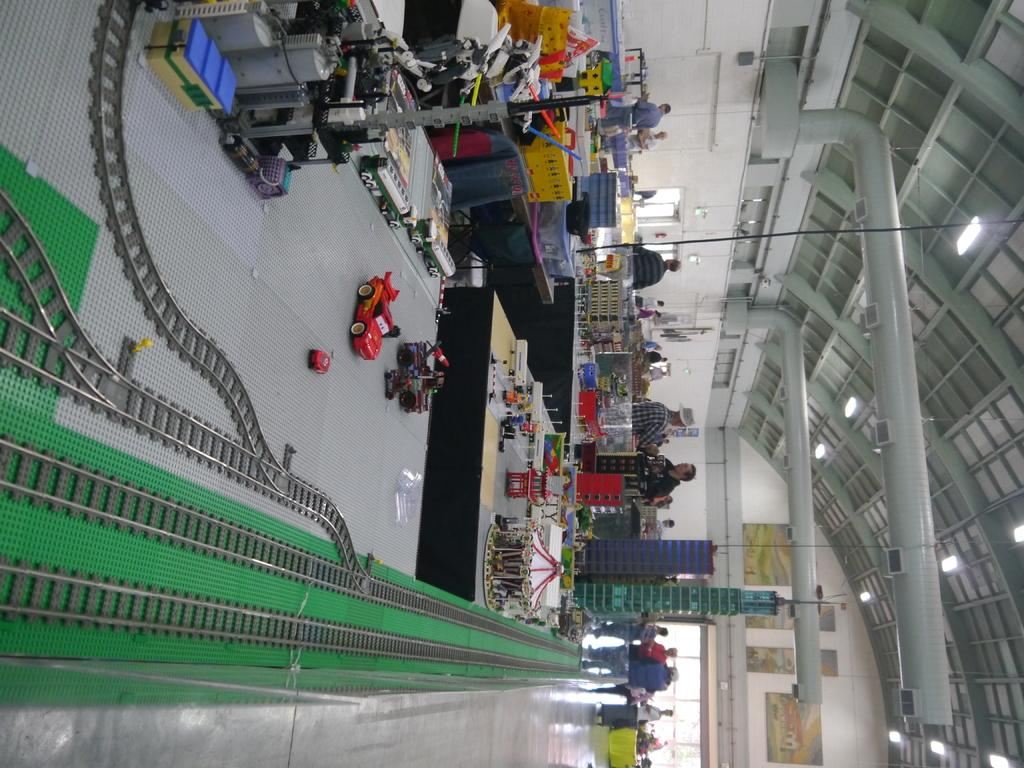What is located at the bottom of the image? There are toy train tracks at the bottom of the image. What can be seen in the middle of the image? There are toys in the middle of the image. Who is present in the image? There are people standing in the image. What type of location does the image appear to depict? The setting appears to be a store. What is visible on the right side of the image? There are lights on the right side of the image. What month is it in the image? The month cannot be determined from the image, as it does not contain any information about the time of year. What type of slope is present in the image? There is no slope present in the image; it depicts a store setting with toy train tracks, toys, people, and lights. 